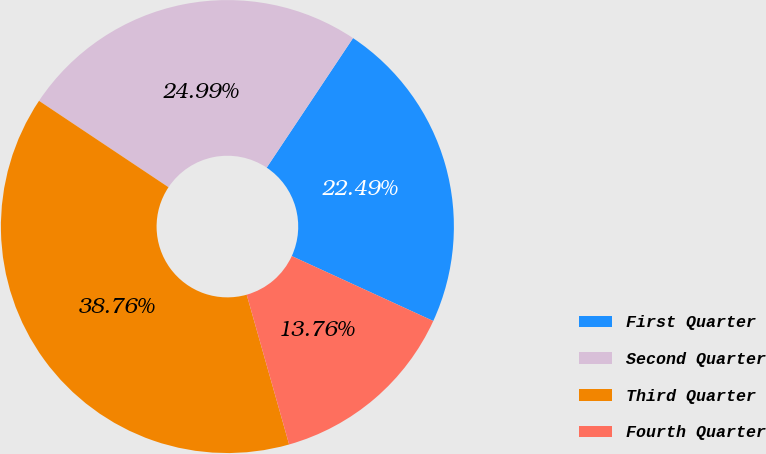Convert chart to OTSL. <chart><loc_0><loc_0><loc_500><loc_500><pie_chart><fcel>First Quarter<fcel>Second Quarter<fcel>Third Quarter<fcel>Fourth Quarter<nl><fcel>22.49%<fcel>24.99%<fcel>38.76%<fcel>13.76%<nl></chart> 